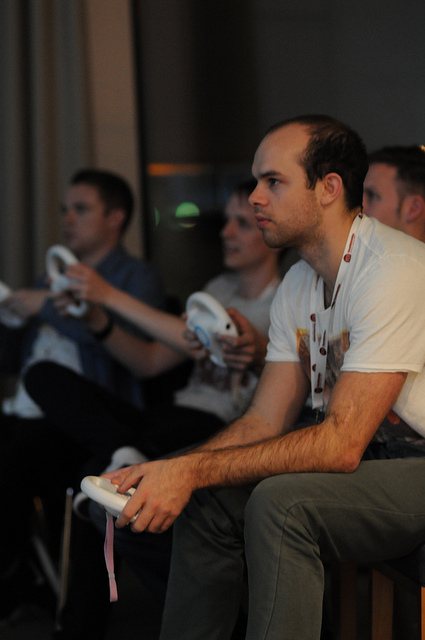<image>Which person has a red bracelet on? There is no one with a red bracelet on in the image. What hand is the person holding on the top? I am not sure what hand the person is holding on the top. The responses vary between 'right', 'left', 'both', or 'none'. Which person has a red bracelet on? There is no person with a red bracelet on. What hand is the person holding on the top? I don't know what hand the person is holding on the top. It can be both left or right. 